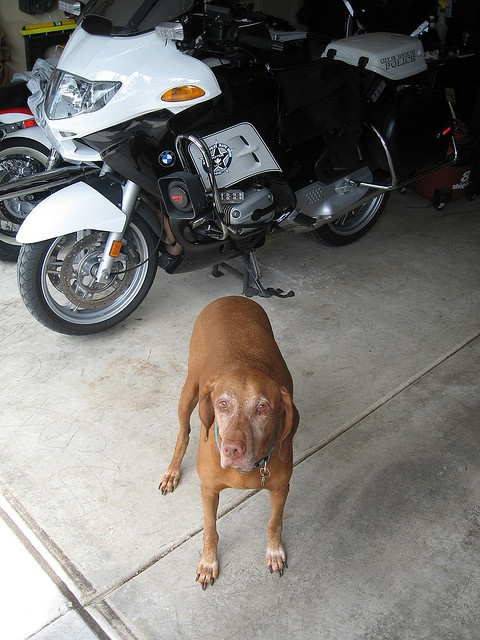Describe the objects in this image and their specific colors. I can see motorcycle in gray, black, lightgray, and darkgray tones, dog in gray, maroon, brown, and tan tones, and motorcycle in gray, black, darkgray, and lightblue tones in this image. 